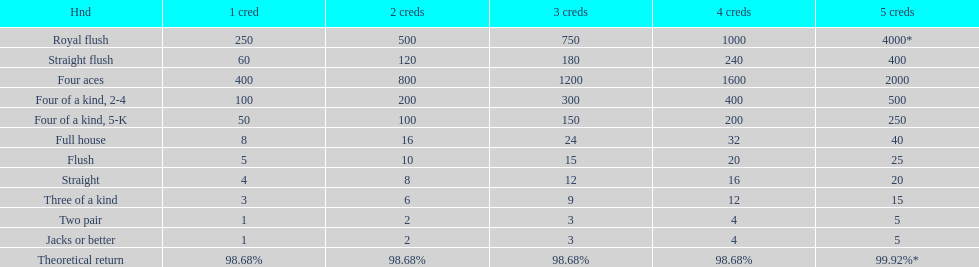How many credits do you have to spend to get at least 2000 in payout if you had four aces? 5 credits. 